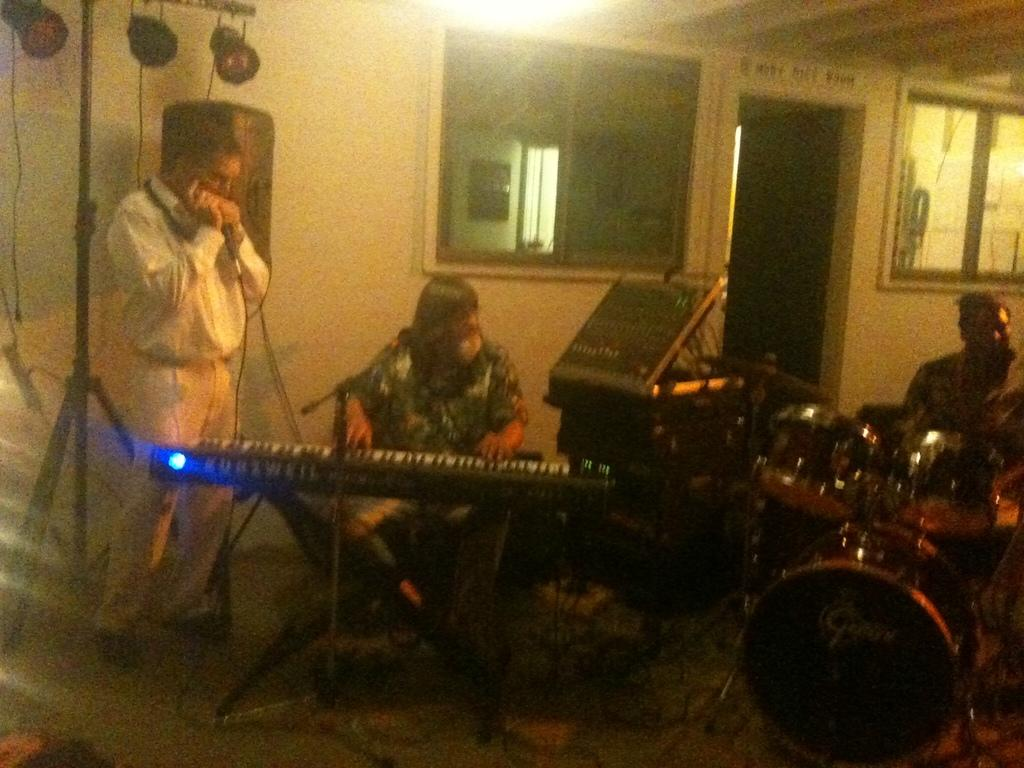What are the people in the image doing? The people in the image are playing musical instruments. Can you describe the setting where the people are playing their instruments? The people are standing behind a wall in a room. What type of insect can be seen crawling on the heat in the image? There is no heat or insect present in the image. 